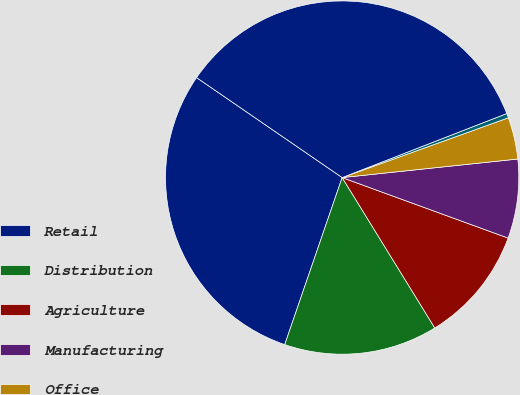Convert chart. <chart><loc_0><loc_0><loc_500><loc_500><pie_chart><fcel>Retail<fcel>Distribution<fcel>Agriculture<fcel>Manufacturing<fcel>Office<fcel>Industrial<fcel>Totals<nl><fcel>29.31%<fcel>14.06%<fcel>10.65%<fcel>7.24%<fcel>3.82%<fcel>0.41%<fcel>34.52%<nl></chart> 